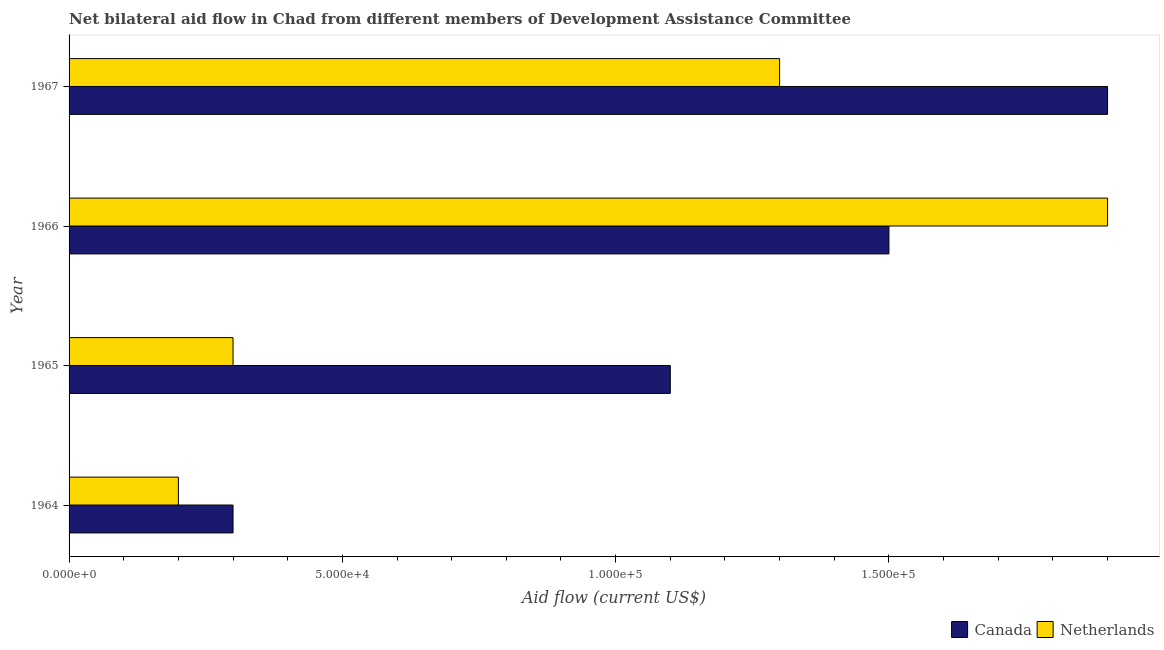Are the number of bars on each tick of the Y-axis equal?
Give a very brief answer. Yes. What is the label of the 4th group of bars from the top?
Your response must be concise. 1964. In how many cases, is the number of bars for a given year not equal to the number of legend labels?
Keep it short and to the point. 0. What is the amount of aid given by netherlands in 1967?
Your answer should be very brief. 1.30e+05. Across all years, what is the maximum amount of aid given by canada?
Provide a succinct answer. 1.90e+05. Across all years, what is the minimum amount of aid given by netherlands?
Offer a very short reply. 2.00e+04. In which year was the amount of aid given by canada maximum?
Give a very brief answer. 1967. In which year was the amount of aid given by canada minimum?
Your answer should be very brief. 1964. What is the total amount of aid given by netherlands in the graph?
Your response must be concise. 3.70e+05. What is the difference between the amount of aid given by netherlands in 1965 and that in 1967?
Provide a short and direct response. -1.00e+05. What is the difference between the amount of aid given by canada in 1965 and the amount of aid given by netherlands in 1964?
Make the answer very short. 9.00e+04. What is the average amount of aid given by canada per year?
Make the answer very short. 1.20e+05. In the year 1966, what is the difference between the amount of aid given by canada and amount of aid given by netherlands?
Provide a short and direct response. -4.00e+04. What is the ratio of the amount of aid given by netherlands in 1964 to that in 1965?
Give a very brief answer. 0.67. Is the difference between the amount of aid given by netherlands in 1964 and 1967 greater than the difference between the amount of aid given by canada in 1964 and 1967?
Ensure brevity in your answer.  Yes. What is the difference between the highest and the second highest amount of aid given by netherlands?
Your answer should be very brief. 6.00e+04. What is the difference between the highest and the lowest amount of aid given by canada?
Your answer should be compact. 1.60e+05. In how many years, is the amount of aid given by netherlands greater than the average amount of aid given by netherlands taken over all years?
Offer a terse response. 2. What does the 1st bar from the bottom in 1967 represents?
Your answer should be very brief. Canada. Are all the bars in the graph horizontal?
Give a very brief answer. Yes. How many years are there in the graph?
Give a very brief answer. 4. How many legend labels are there?
Your response must be concise. 2. What is the title of the graph?
Provide a short and direct response. Net bilateral aid flow in Chad from different members of Development Assistance Committee. Does "Revenue" appear as one of the legend labels in the graph?
Offer a terse response. No. What is the Aid flow (current US$) in Canada in 1964?
Your response must be concise. 3.00e+04. What is the Aid flow (current US$) in Netherlands in 1967?
Give a very brief answer. 1.30e+05. Across all years, what is the maximum Aid flow (current US$) in Netherlands?
Make the answer very short. 1.90e+05. What is the total Aid flow (current US$) in Netherlands in the graph?
Keep it short and to the point. 3.70e+05. What is the difference between the Aid flow (current US$) of Netherlands in 1964 and that in 1965?
Offer a very short reply. -10000. What is the difference between the Aid flow (current US$) of Canada in 1965 and that in 1966?
Keep it short and to the point. -4.00e+04. What is the difference between the Aid flow (current US$) of Canada in 1965 and that in 1967?
Offer a terse response. -8.00e+04. What is the difference between the Aid flow (current US$) of Canada in 1966 and that in 1967?
Keep it short and to the point. -4.00e+04. What is the difference between the Aid flow (current US$) in Canada in 1964 and the Aid flow (current US$) in Netherlands in 1965?
Keep it short and to the point. 0. What is the difference between the Aid flow (current US$) of Canada in 1966 and the Aid flow (current US$) of Netherlands in 1967?
Your answer should be very brief. 2.00e+04. What is the average Aid flow (current US$) in Canada per year?
Your answer should be compact. 1.20e+05. What is the average Aid flow (current US$) of Netherlands per year?
Give a very brief answer. 9.25e+04. In the year 1967, what is the difference between the Aid flow (current US$) of Canada and Aid flow (current US$) of Netherlands?
Offer a very short reply. 6.00e+04. What is the ratio of the Aid flow (current US$) of Canada in 1964 to that in 1965?
Give a very brief answer. 0.27. What is the ratio of the Aid flow (current US$) of Netherlands in 1964 to that in 1966?
Provide a succinct answer. 0.11. What is the ratio of the Aid flow (current US$) in Canada in 1964 to that in 1967?
Your answer should be very brief. 0.16. What is the ratio of the Aid flow (current US$) in Netherlands in 1964 to that in 1967?
Make the answer very short. 0.15. What is the ratio of the Aid flow (current US$) of Canada in 1965 to that in 1966?
Make the answer very short. 0.73. What is the ratio of the Aid flow (current US$) of Netherlands in 1965 to that in 1966?
Offer a very short reply. 0.16. What is the ratio of the Aid flow (current US$) in Canada in 1965 to that in 1967?
Make the answer very short. 0.58. What is the ratio of the Aid flow (current US$) of Netherlands in 1965 to that in 1967?
Keep it short and to the point. 0.23. What is the ratio of the Aid flow (current US$) of Canada in 1966 to that in 1967?
Offer a terse response. 0.79. What is the ratio of the Aid flow (current US$) in Netherlands in 1966 to that in 1967?
Provide a succinct answer. 1.46. What is the difference between the highest and the lowest Aid flow (current US$) of Netherlands?
Give a very brief answer. 1.70e+05. 